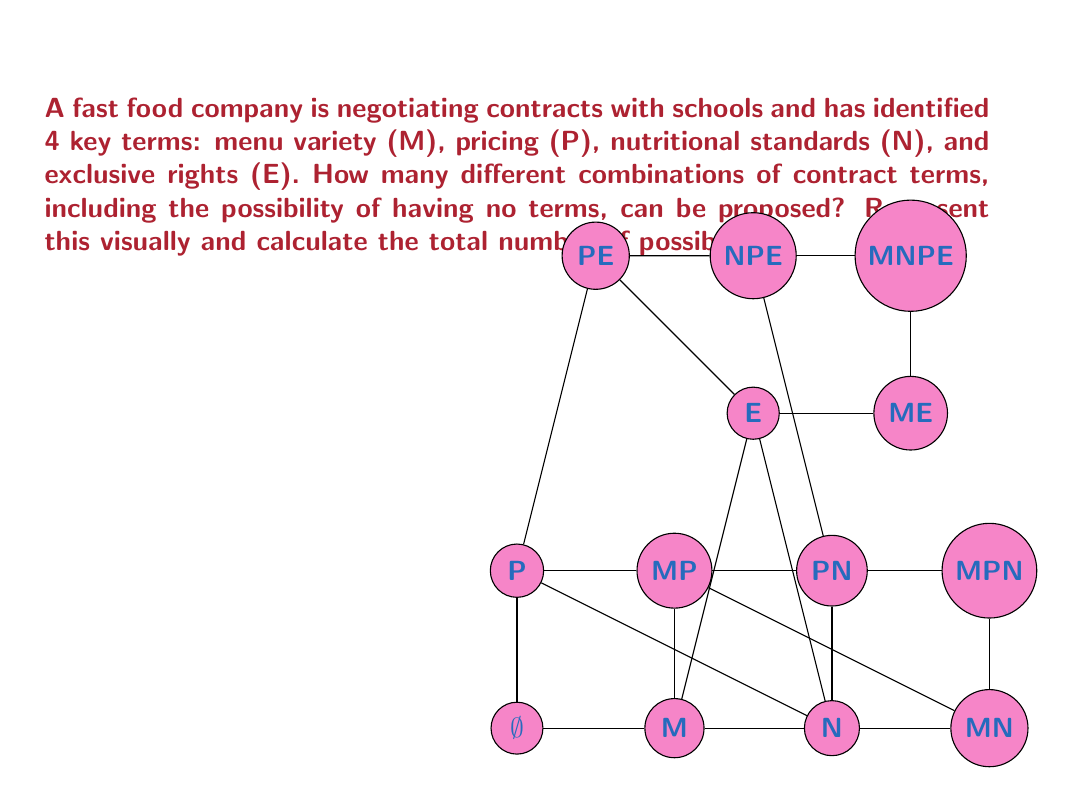Can you solve this math problem? To solve this problem, we need to understand the concept of power sets in set theory.

1) First, let's identify our set of contract terms:
   $S = \{M, P, N, E\}$

2) The power set of S, denoted as $P(S)$, is the set of all possible subsets of S, including the empty set and S itself.

3) To calculate the number of elements in the power set, we use the formula:
   $|P(S)| = 2^n$, where n is the number of elements in the original set.

4) In this case, $n = 4$, so:
   $|P(S)| = 2^4 = 16$

5) We can list all these possibilities:
   - $\{\}$ (empty set)
   - $\{M\}$, $\{P\}$, $\{N\}$, $\{E\}$ (sets with 1 element)
   - $\{M,P\}$, $\{M,N\}$, $\{M,E\}$, $\{P,N\}$, $\{P,E\}$, $\{N,E\}$ (sets with 2 elements)
   - $\{M,P,N\}$, $\{M,P,E\}$, $\{M,N,E\}$, $\{P,N,E\}$ (sets with 3 elements)
   - $\{M,P,N,E\}$ (full set)

6) The visual representation in the question shows all these possibilities as vertices in a 4-dimensional hypercube (tesseract).

Therefore, there are 16 different combinations of contract terms that can be proposed, including the option of having no terms.
Answer: $2^4 = 16$ combinations 